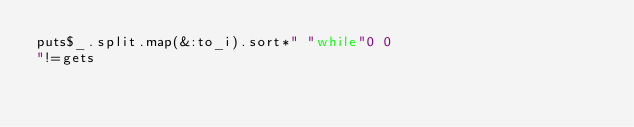Convert code to text. <code><loc_0><loc_0><loc_500><loc_500><_Ruby_>puts$_.split.map(&:to_i).sort*" "while"0 0
"!=gets</code> 